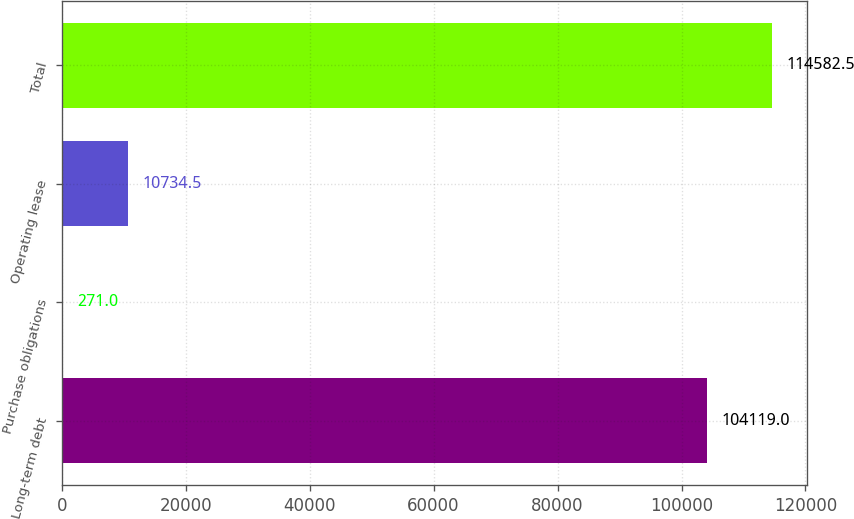<chart> <loc_0><loc_0><loc_500><loc_500><bar_chart><fcel>Long-term debt<fcel>Purchase obligations<fcel>Operating lease<fcel>Total<nl><fcel>104119<fcel>271<fcel>10734.5<fcel>114582<nl></chart> 